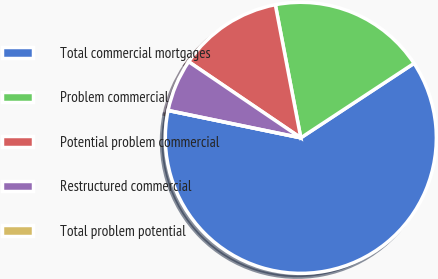Convert chart. <chart><loc_0><loc_0><loc_500><loc_500><pie_chart><fcel>Total commercial mortgages<fcel>Problem commercial<fcel>Potential problem commercial<fcel>Restructured commercial<fcel>Total problem potential<nl><fcel>62.5%<fcel>18.75%<fcel>12.5%<fcel>6.25%<fcel>0.0%<nl></chart> 